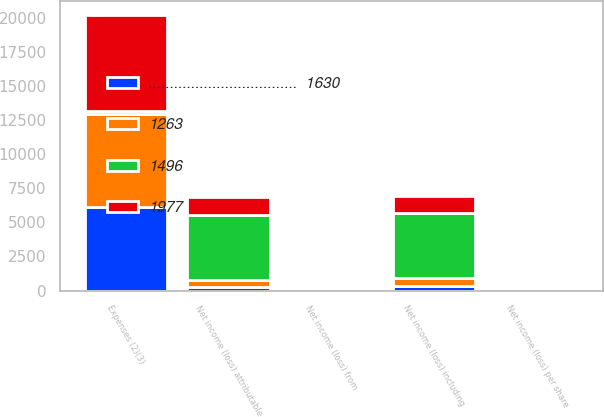Convert chart to OTSL. <chart><loc_0><loc_0><loc_500><loc_500><stacked_bar_chart><ecel><fcel>Expenses (2)(3)<fcel>Net income (loss) from<fcel>Net income (loss) including<fcel>Net income (loss) attributable<fcel>Net income (loss) per share<nl><fcel>...................................  1630<fcel>6134<fcel>1.66<fcel>334<fcel>236<fcel>0.6<nl><fcel>1263<fcel>6809<fcel>1.17<fcel>613<fcel>505<fcel>1.31<nl><fcel>1977<fcel>7047<fcel>3.08<fcel>1241<fcel>1330<fcel>3.5<nl><fcel>1496<fcel>236<fcel>9.93<fcel>4766<fcel>4814<fcel>12.78<nl></chart> 